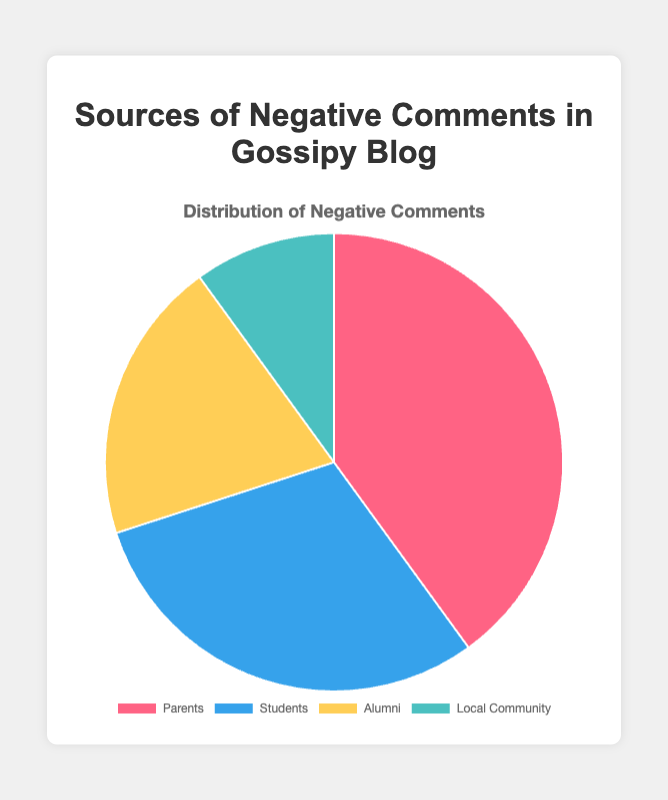Which source has the largest percentage of negative comments? The largest percentage can be identified by looking for the largest slice in the pie chart or the highest value labeled. In this case, it's "Parents" with 40%.
Answer: Parents Which two sources together contribute to half of the negative comments? Adding up the percentages, "Parents" (40%) and "Students" (30%) together make 70%, which is more than half. We need to find a pair totaling 50%, so we instead add "Alumni" (20%) and "Students" (30%) equaling 50%.
Answer: Students and Alumni By how much does the percentage of negative comments from Parents exceed those from the Local Community? Subtract the percentage of Local Community from Parents: 40% - 10% = 30%.
Answer: 30% If the negative comments from Alumni doubled, what would be the new percentage for Alumni, and would it then lead the other sources? Doubling Alumni's percentage: 20% * 2 = 40%. Comparing it with other sources, it ties with Parents at 40%.
Answer: 40%, Yes (tied with Parents) Which sources have less than a quarter of the total negative comments? A quarter (25%) of the total is calculated as 100% / 4 = 25%. Sources below this threshold are "Alumni" (20%) and "Local Community" (10%).
Answer: Alumni and Local Community How does the percentage of negative comments from Students compare to half the total negative comments? Half of the total is calculated as 100% / 2 = 50%. The Students' percentage is 30%, which is less than half the total.
Answer: Less than half What is the total percentage of negative comments contributed by Parents and Students? Sum the percentages of Parents and Students: 40% + 30% = 70%.
Answer: 70% What color represents the segment of the pie chart with the smallest percentage of negative comments? Identify the smallest segment visually or by the smallest labeled value, which is the "Local Community" at 10%. The color is indicated by the color legend in the chart and descriptions.
Answer: Light blue (or #4BC0C0 as per the code provided) Does any single source contribute to more than one-third of the total negative comments? One-third is 100% / 3 = approximately 33.33%. "Parents" contribute 40%, which is more than one-third.
Answer: Yes (Parents) Are the negative comments equally distributed among the four sources? Check if all four sources have the same percentage values. The percentages are 40%, 30%, 20%, and 10%, which are not equal.
Answer: No 